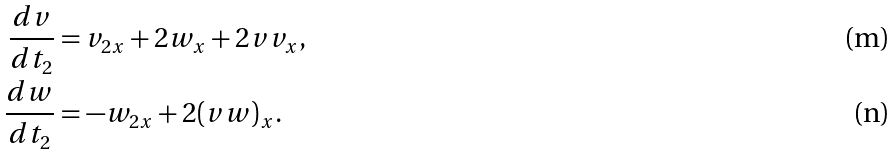Convert formula to latex. <formula><loc_0><loc_0><loc_500><loc_500>\frac { d v } { d t _ { 2 } } & = v _ { 2 x } + 2 w _ { x } + 2 v v _ { x } , \\ \frac { d w } { d t _ { 2 } } & = - w _ { 2 x } + 2 ( v w ) _ { x } .</formula> 